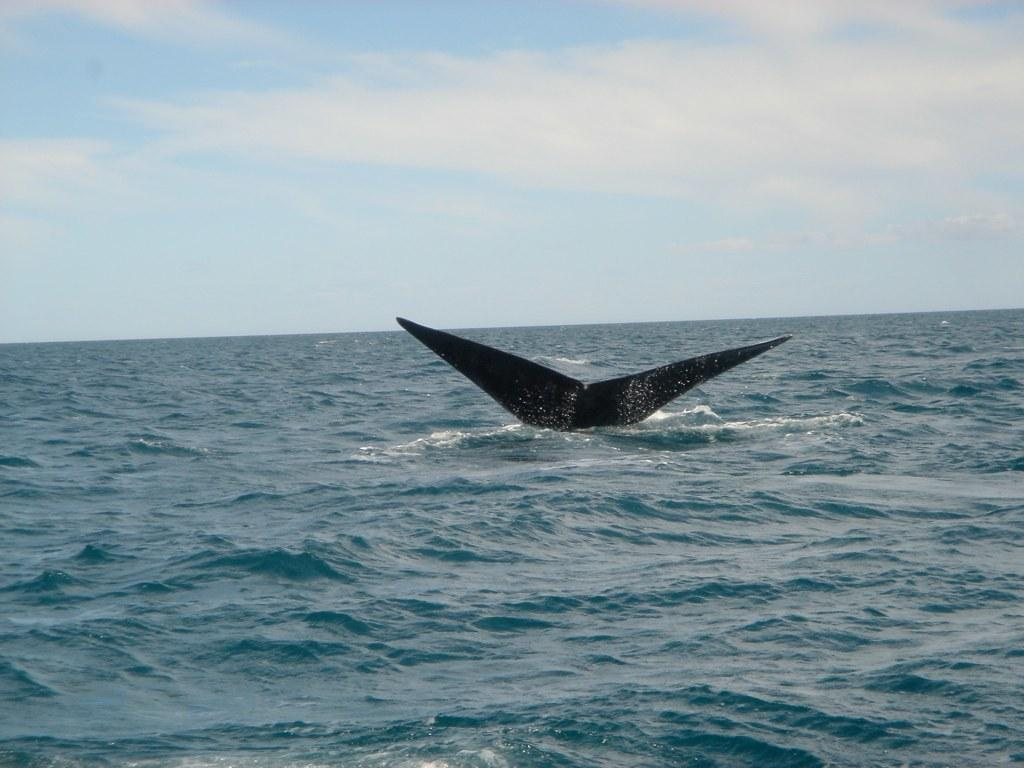What is the main subject of the image? The main subject of the image is a fishtail. What is the environment surrounding the fishtail? There is water visible in the image. What can be seen in the background of the image? The sky is visible in the background of the image. What is the condition of the sky in the image? Clouds are present in the sky. What type of twist can be seen in the image? There is no twist present in the image; it features a fishtail in water with clouds in the sky. How many quinces are visible in the image? There are no quinces present in the image. 